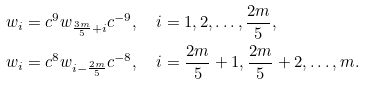Convert formula to latex. <formula><loc_0><loc_0><loc_500><loc_500>w _ { i } & = c ^ { 9 } w _ { \frac { 3 m } 5 + i } c ^ { - 9 } , \quad i = 1 , 2 , \dots , \frac { 2 m } 5 , \\ w _ { i } & = c ^ { 8 } w _ { i - \frac { 2 m } 5 } c ^ { - 8 } , \quad i = \frac { 2 m } 5 + 1 , \frac { 2 m } 5 + 2 , \dots , m .</formula> 